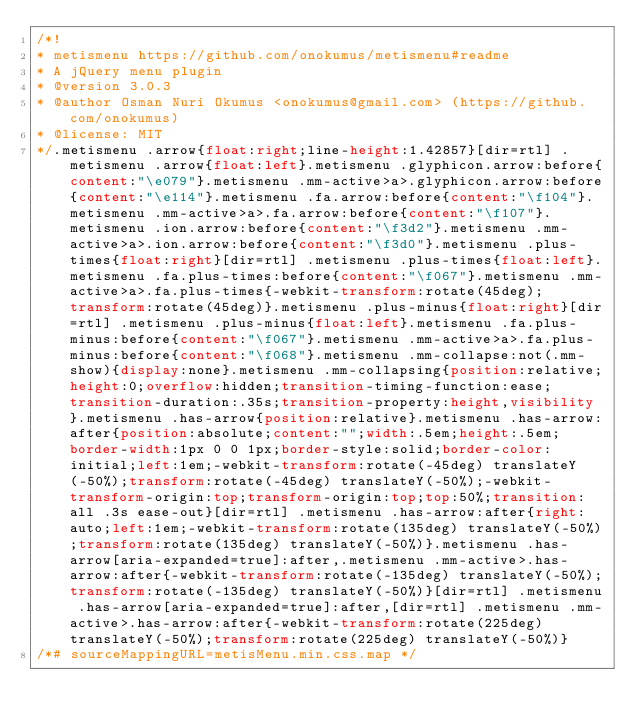<code> <loc_0><loc_0><loc_500><loc_500><_CSS_>/*!
* metismenu https://github.com/onokumus/metismenu#readme
* A jQuery menu plugin
* @version 3.0.3
* @author Osman Nuri Okumus <onokumus@gmail.com> (https://github.com/onokumus)
* @license: MIT 
*/.metismenu .arrow{float:right;line-height:1.42857}[dir=rtl] .metismenu .arrow{float:left}.metismenu .glyphicon.arrow:before{content:"\e079"}.metismenu .mm-active>a>.glyphicon.arrow:before{content:"\e114"}.metismenu .fa.arrow:before{content:"\f104"}.metismenu .mm-active>a>.fa.arrow:before{content:"\f107"}.metismenu .ion.arrow:before{content:"\f3d2"}.metismenu .mm-active>a>.ion.arrow:before{content:"\f3d0"}.metismenu .plus-times{float:right}[dir=rtl] .metismenu .plus-times{float:left}.metismenu .fa.plus-times:before{content:"\f067"}.metismenu .mm-active>a>.fa.plus-times{-webkit-transform:rotate(45deg);transform:rotate(45deg)}.metismenu .plus-minus{float:right}[dir=rtl] .metismenu .plus-minus{float:left}.metismenu .fa.plus-minus:before{content:"\f067"}.metismenu .mm-active>a>.fa.plus-minus:before{content:"\f068"}.metismenu .mm-collapse:not(.mm-show){display:none}.metismenu .mm-collapsing{position:relative;height:0;overflow:hidden;transition-timing-function:ease;transition-duration:.35s;transition-property:height,visibility}.metismenu .has-arrow{position:relative}.metismenu .has-arrow:after{position:absolute;content:"";width:.5em;height:.5em;border-width:1px 0 0 1px;border-style:solid;border-color:initial;left:1em;-webkit-transform:rotate(-45deg) translateY(-50%);transform:rotate(-45deg) translateY(-50%);-webkit-transform-origin:top;transform-origin:top;top:50%;transition:all .3s ease-out}[dir=rtl] .metismenu .has-arrow:after{right:auto;left:1em;-webkit-transform:rotate(135deg) translateY(-50%);transform:rotate(135deg) translateY(-50%)}.metismenu .has-arrow[aria-expanded=true]:after,.metismenu .mm-active>.has-arrow:after{-webkit-transform:rotate(-135deg) translateY(-50%);transform:rotate(-135deg) translateY(-50%)}[dir=rtl] .metismenu .has-arrow[aria-expanded=true]:after,[dir=rtl] .metismenu .mm-active>.has-arrow:after{-webkit-transform:rotate(225deg) translateY(-50%);transform:rotate(225deg) translateY(-50%)}
/*# sourceMappingURL=metisMenu.min.css.map */</code> 